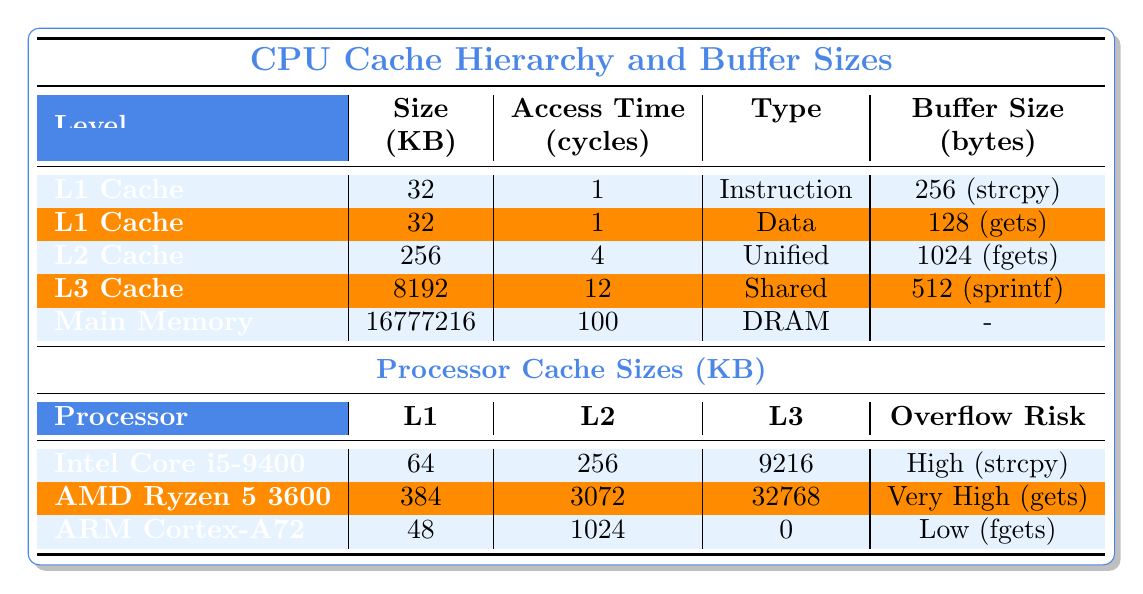What is the access time for L2 Cache? The table lists the access time for each cache level, and for L2 Cache, it shows an access time of 4 cycles.
Answer: 4 cycles Which cache type has the largest size? Comparing the sizes of all caches in the table, the Main Memory has the largest size at 16 GB, or 16777216 KB.
Answer: 16777216 KB Does the ARM Cortex-A72 have an L3 Cache? The table shows that the ARM Cortex-A72 has an L3 Cache size of 0, indicating that it does not have an effective L3 Cache.
Answer: No What is the combined size of all L1 Cache levels? The L1 Cache size for both Instruction and Data caches is 32 KB each, so the combined size is 32 KB + 32 KB = 64 KB.
Answer: 64 KB Which processor has the highest L2 Cache size? By examining the L2 Cache sizes, the AMD Ryzen 5 3600 has the largest L2 Cache at 3072 KB compared to the others.
Answer: AMD Ryzen 5 3600 What is the average access time for all cache levels listed? To calculate the average access time, sum the access times: (1 + 1 + 4 + 12 + 100) = 118 cycles; there are 5 cache levels, so the average is 118 / 5 = 23.6 cycles.
Answer: 23.6 cycles Which cache level has the highest overflow risk associated with its buffer? The table indicates that the buffer risk is highest for "gets," which is associated with the L1 Data Cache (128 bytes).
Answer: L1 Data Cache Is the L3 Cache access time faster than the Main Memory access time? The table shows the L3 Cache access time is 12 cycles, while the Main Memory access time is 100 cycles; thus, L3 Cache is indeed faster.
Answer: Yes What is the total size of L1 Cache across all processors? Each processor's L1 Cache size is summed: 64 + 384 + 48 = 496 KB.
Answer: 496 KB Does the Intel Core i5-9400's L3 Cache size exceed 8 MB? The Intel Core i5-9400 has a L3 Cache size of 9216 KB, which is larger than 8 MB (8192 KB).
Answer: Yes 